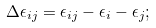<formula> <loc_0><loc_0><loc_500><loc_500>\Delta \epsilon _ { i j } = \epsilon _ { i j } - \epsilon _ { i } - \epsilon _ { j } ;</formula> 